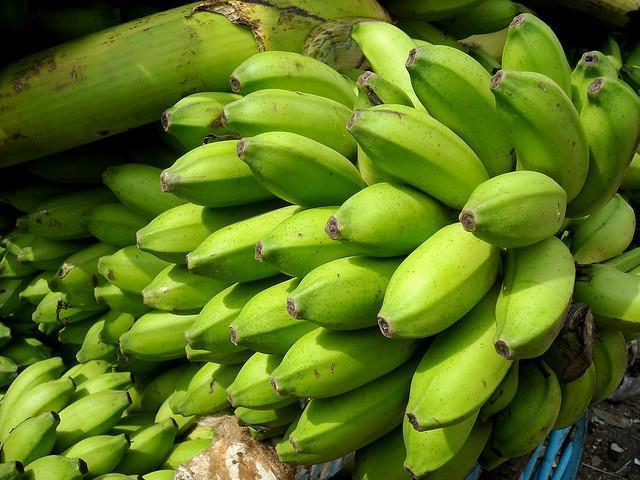How many bananas are visible?
Give a very brief answer. 2. 